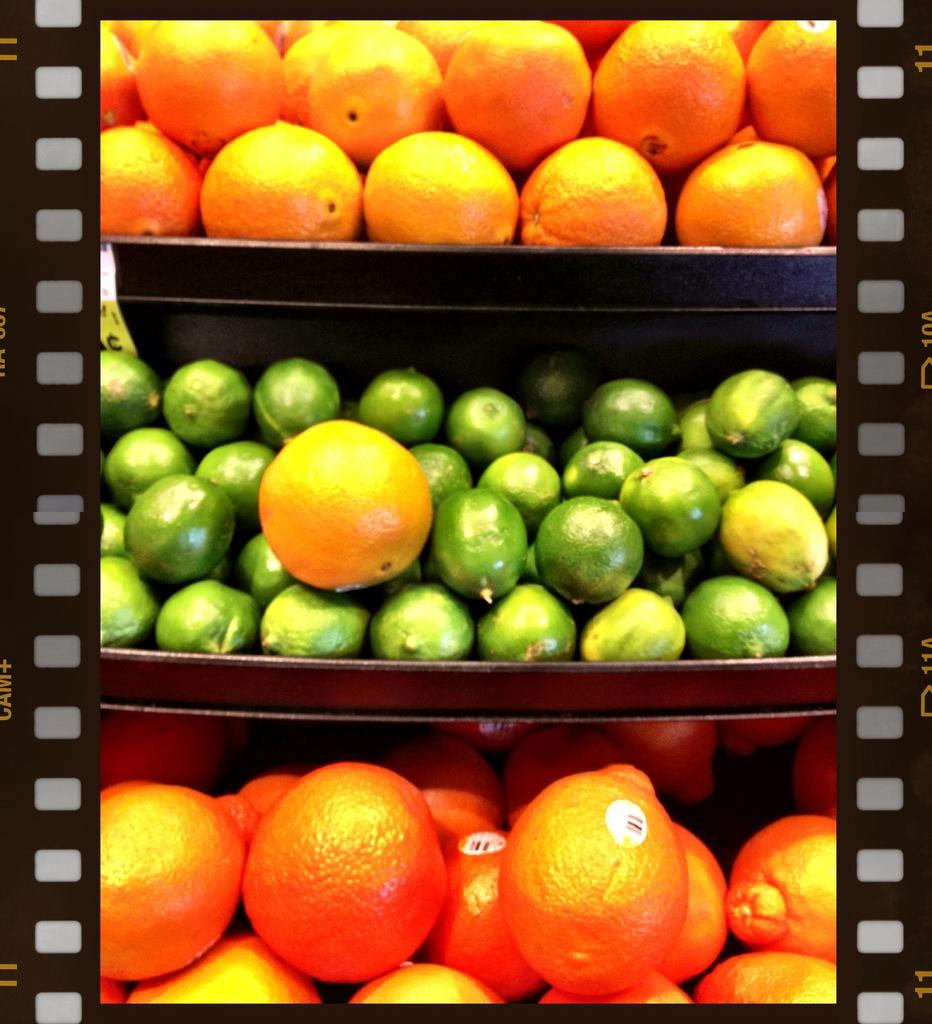What can be observed about the image's appearance? The image is edited. What type of objects are present in the image? There are fruits in the image. How are the fruits arranged in the image? The fruits are placed on shelves. How many kittens are playing with the fruits on the shelves in the image? There are no kittens present in the image; it only features fruits on shelves. What is the memory capacity of the shelves in the image? The shelves in the image do not have a memory capacity, as they are physical objects used for storage and not electronic devices. 